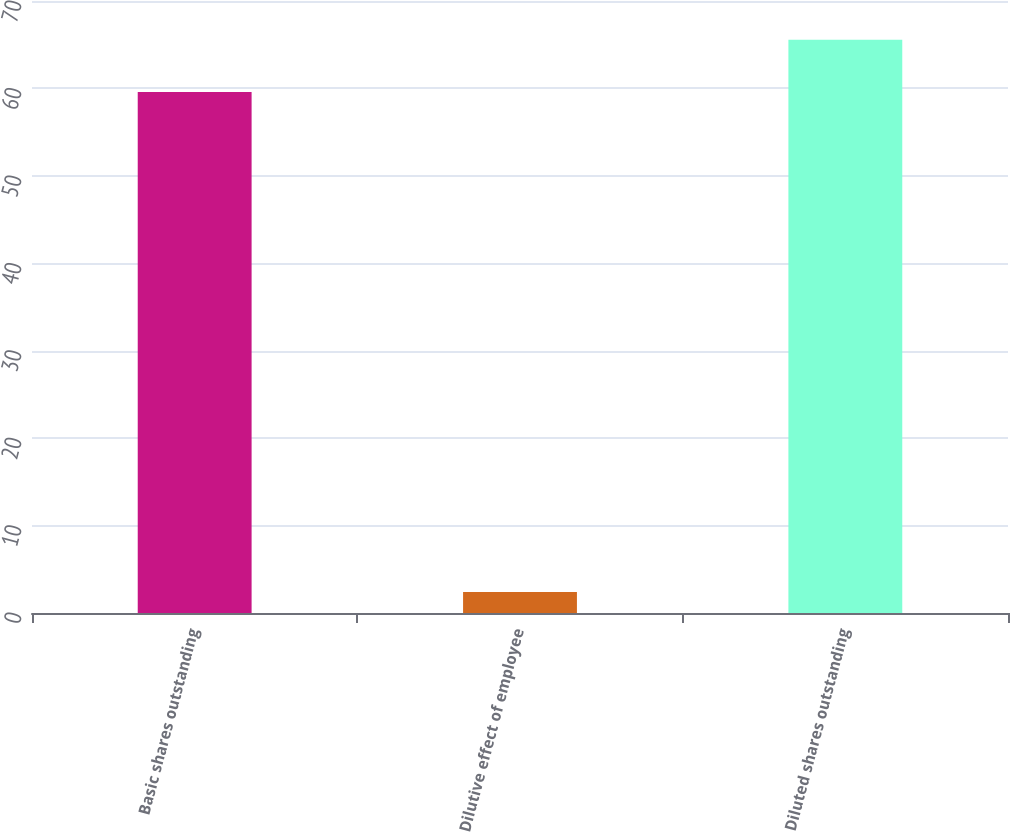<chart> <loc_0><loc_0><loc_500><loc_500><bar_chart><fcel>Basic shares outstanding<fcel>Dilutive effect of employee<fcel>Diluted shares outstanding<nl><fcel>59.6<fcel>2.4<fcel>65.56<nl></chart> 